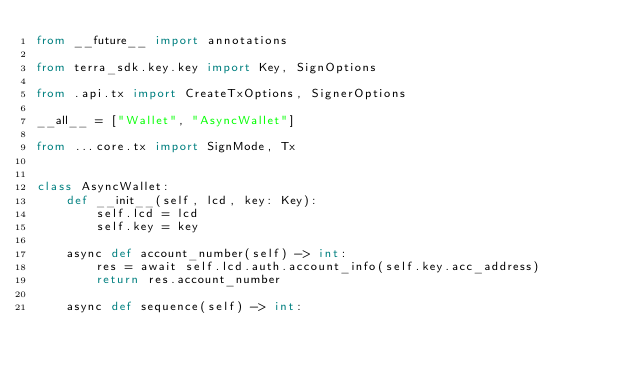<code> <loc_0><loc_0><loc_500><loc_500><_Python_>from __future__ import annotations

from terra_sdk.key.key import Key, SignOptions

from .api.tx import CreateTxOptions, SignerOptions

__all__ = ["Wallet", "AsyncWallet"]

from ...core.tx import SignMode, Tx


class AsyncWallet:
    def __init__(self, lcd, key: Key):
        self.lcd = lcd
        self.key = key

    async def account_number(self) -> int:
        res = await self.lcd.auth.account_info(self.key.acc_address)
        return res.account_number

    async def sequence(self) -> int:</code> 